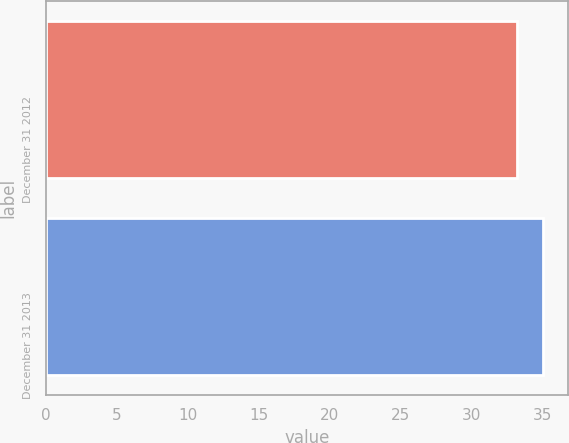<chart> <loc_0><loc_0><loc_500><loc_500><bar_chart><fcel>December 31 2012<fcel>December 31 2013<nl><fcel>33.18<fcel>35.04<nl></chart> 